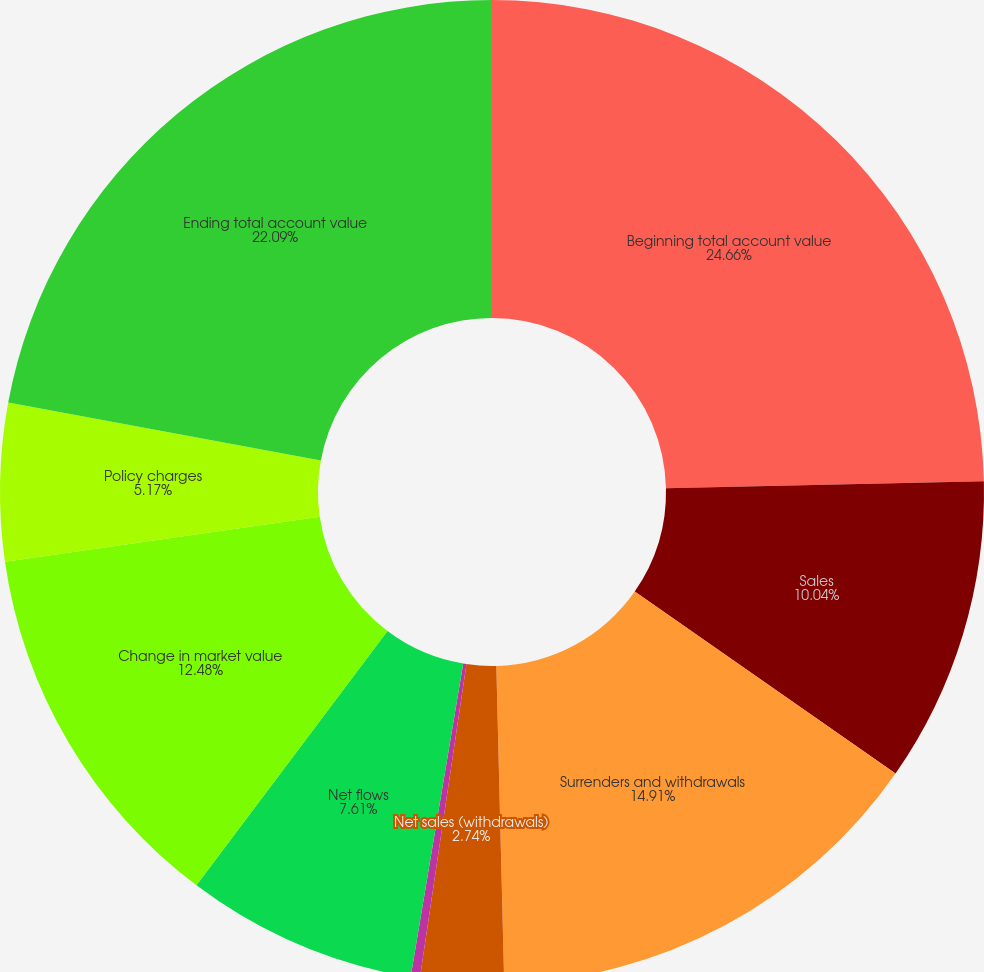Convert chart to OTSL. <chart><loc_0><loc_0><loc_500><loc_500><pie_chart><fcel>Beginning total account value<fcel>Sales<fcel>Surrenders and withdrawals<fcel>Net sales (withdrawals)<fcel>Benefit payments<fcel>Net flows<fcel>Change in market value<fcel>Policy charges<fcel>Ending total account value<nl><fcel>24.65%<fcel>10.04%<fcel>14.91%<fcel>2.74%<fcel>0.3%<fcel>7.61%<fcel>12.48%<fcel>5.17%<fcel>22.09%<nl></chart> 